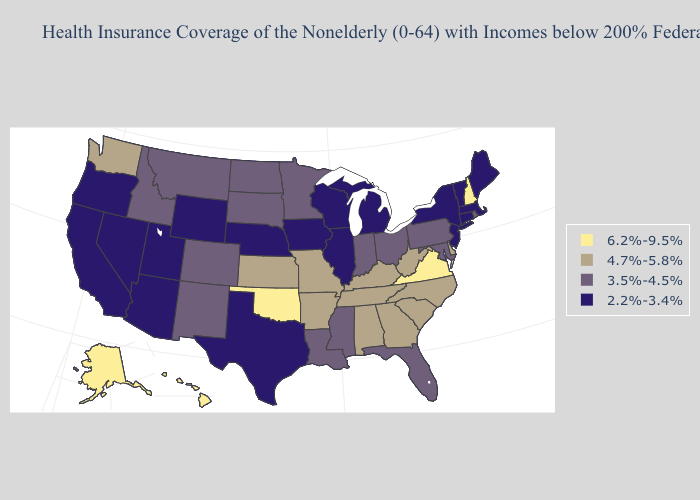Name the states that have a value in the range 2.2%-3.4%?
Concise answer only. Arizona, California, Connecticut, Illinois, Iowa, Maine, Massachusetts, Michigan, Nebraska, Nevada, New Jersey, New York, Oregon, Texas, Utah, Vermont, Wisconsin, Wyoming. Name the states that have a value in the range 4.7%-5.8%?
Give a very brief answer. Alabama, Arkansas, Delaware, Georgia, Kansas, Kentucky, Missouri, North Carolina, South Carolina, Tennessee, Washington, West Virginia. Name the states that have a value in the range 4.7%-5.8%?
Answer briefly. Alabama, Arkansas, Delaware, Georgia, Kansas, Kentucky, Missouri, North Carolina, South Carolina, Tennessee, Washington, West Virginia. Which states have the lowest value in the Northeast?
Be succinct. Connecticut, Maine, Massachusetts, New Jersey, New York, Vermont. What is the lowest value in the USA?
Answer briefly. 2.2%-3.4%. Does Alaska have the highest value in the West?
Concise answer only. Yes. What is the value of Wisconsin?
Answer briefly. 2.2%-3.4%. Among the states that border Maryland , does Virginia have the lowest value?
Be succinct. No. How many symbols are there in the legend?
Answer briefly. 4. Name the states that have a value in the range 6.2%-9.5%?
Give a very brief answer. Alaska, Hawaii, New Hampshire, Oklahoma, Virginia. Does North Carolina have the lowest value in the USA?
Give a very brief answer. No. Among the states that border North Carolina , does Georgia have the highest value?
Be succinct. No. What is the value of Utah?
Answer briefly. 2.2%-3.4%. Does Tennessee have the same value as Colorado?
Concise answer only. No. What is the value of Oklahoma?
Concise answer only. 6.2%-9.5%. 